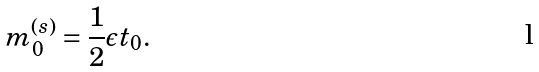Convert formula to latex. <formula><loc_0><loc_0><loc_500><loc_500>m _ { 0 } ^ { ( s ) } = \frac { 1 } { 2 } \epsilon t _ { 0 } .</formula> 